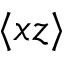Convert formula to latex. <formula><loc_0><loc_0><loc_500><loc_500>\langle x z \rangle</formula> 